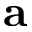Convert formula to latex. <formula><loc_0><loc_0><loc_500><loc_500>{ a }</formula> 